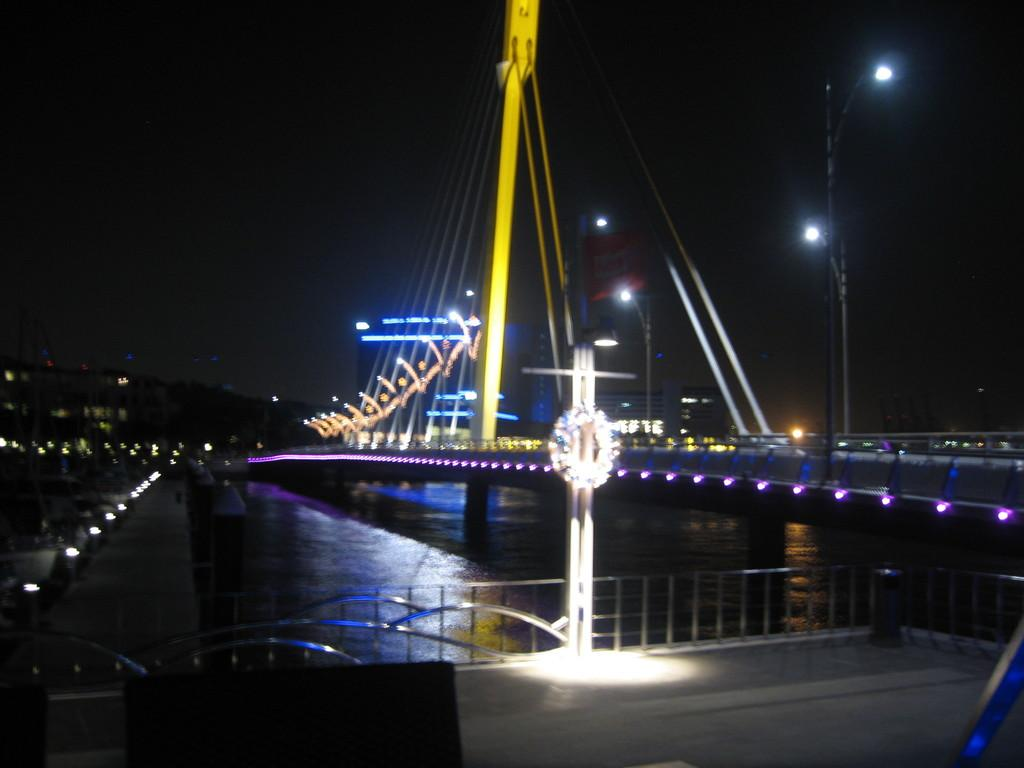What structure is present in the image? There is a bridge in the image. What can be seen under the bridge? There is water under the bridge. What feature is present on the bridge for safety? There is a railing on the bridge. What provides illumination on the bridge at night? There are street lights on the bridge. What type of caption is written on the bridge in the image? There is no caption present on the bridge in the image. 